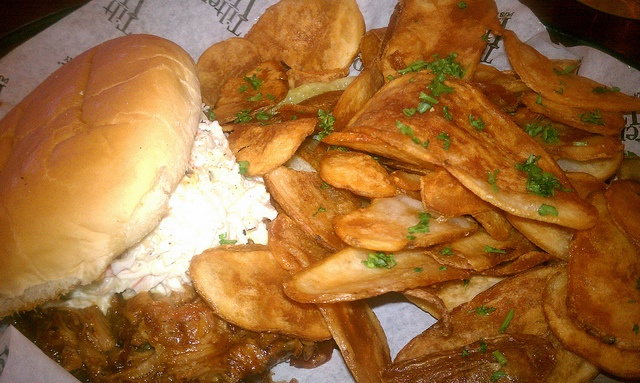Describe the objects in this image and their specific colors. I can see a sandwich in black, brown, ivory, khaki, and orange tones in this image. 